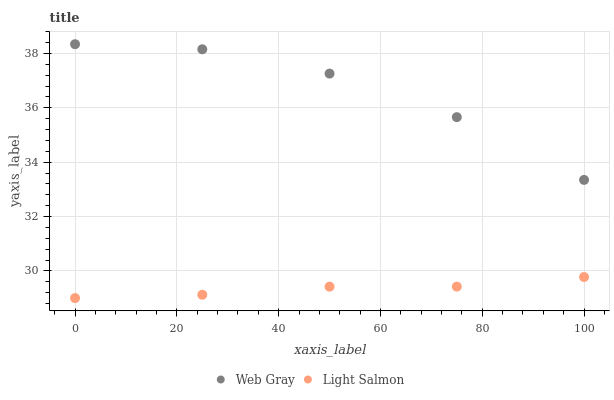Does Light Salmon have the minimum area under the curve?
Answer yes or no. Yes. Does Web Gray have the maximum area under the curve?
Answer yes or no. Yes. Does Web Gray have the minimum area under the curve?
Answer yes or no. No. Is Light Salmon the smoothest?
Answer yes or no. Yes. Is Web Gray the roughest?
Answer yes or no. Yes. Is Web Gray the smoothest?
Answer yes or no. No. Does Light Salmon have the lowest value?
Answer yes or no. Yes. Does Web Gray have the lowest value?
Answer yes or no. No. Does Web Gray have the highest value?
Answer yes or no. Yes. Is Light Salmon less than Web Gray?
Answer yes or no. Yes. Is Web Gray greater than Light Salmon?
Answer yes or no. Yes. Does Light Salmon intersect Web Gray?
Answer yes or no. No. 